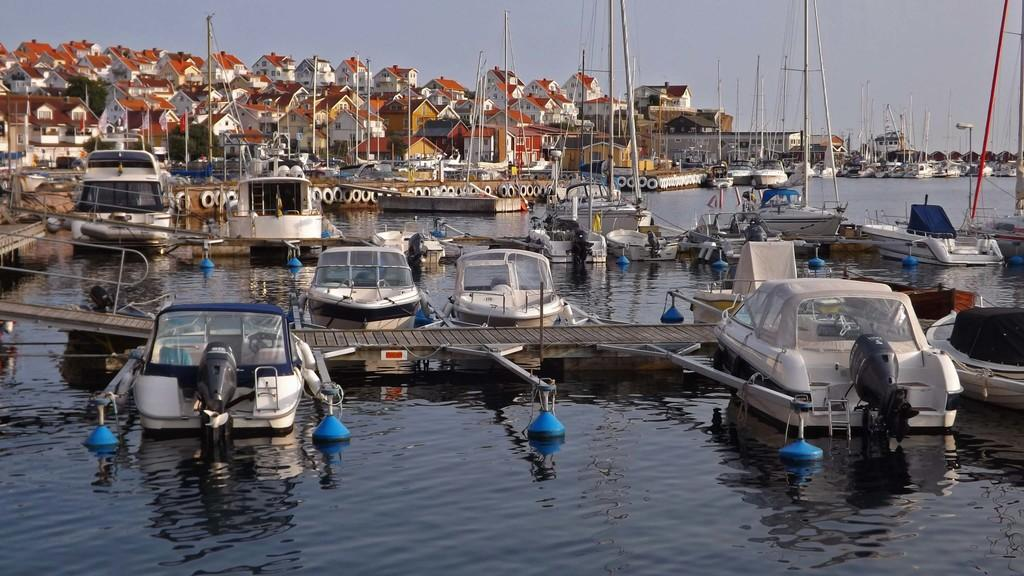What type of vehicles can be seen in the image? There are boats in the image. What structures are present in the image? There are poles, a wooden bridge, and houses in the image. What is visible at the top of the image? The sky is visible at the top of the image. What activity is your dad participating in with the boats in the image? There is no information about your dad or any specific activity in the image. The image only shows boats, poles, a wooden bridge, houses, and the sky. 